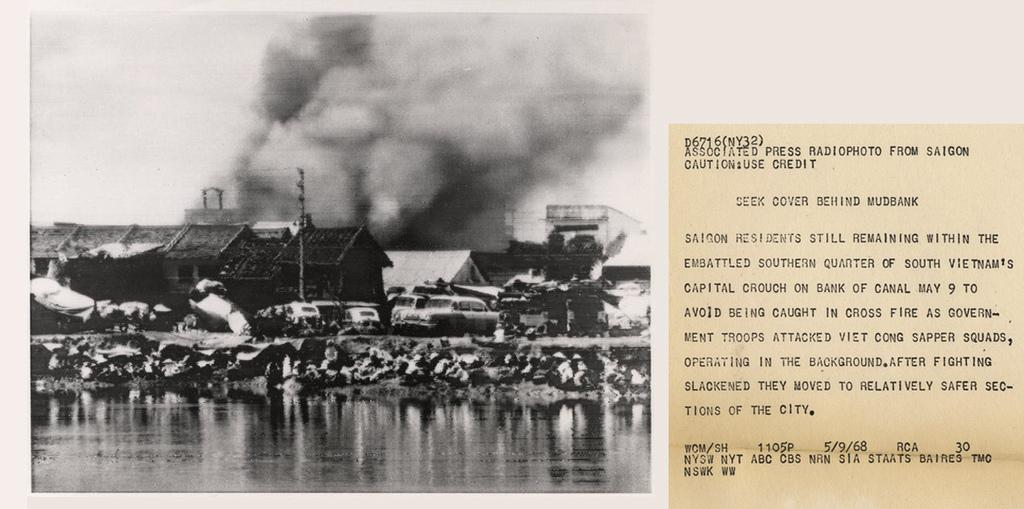What type of artwork is the image? The image is a collage. What structures can be seen in the collage? There are houses in the image. What else can be seen in the collage besides houses? There are vehicles and water visible in the image. What else can be seen in the sky in the image? There is smoke visible in the sky in the image. What else can be seen in the sky in the image? There is sky visible in the image. Is there any text present in the image? Yes, there is some text in the image. How many ants can be seen crawling on the skin in the image? There are no ants or skin present in the image; it is a collage featuring houses, vehicles, water, smoke, sky, and text. 